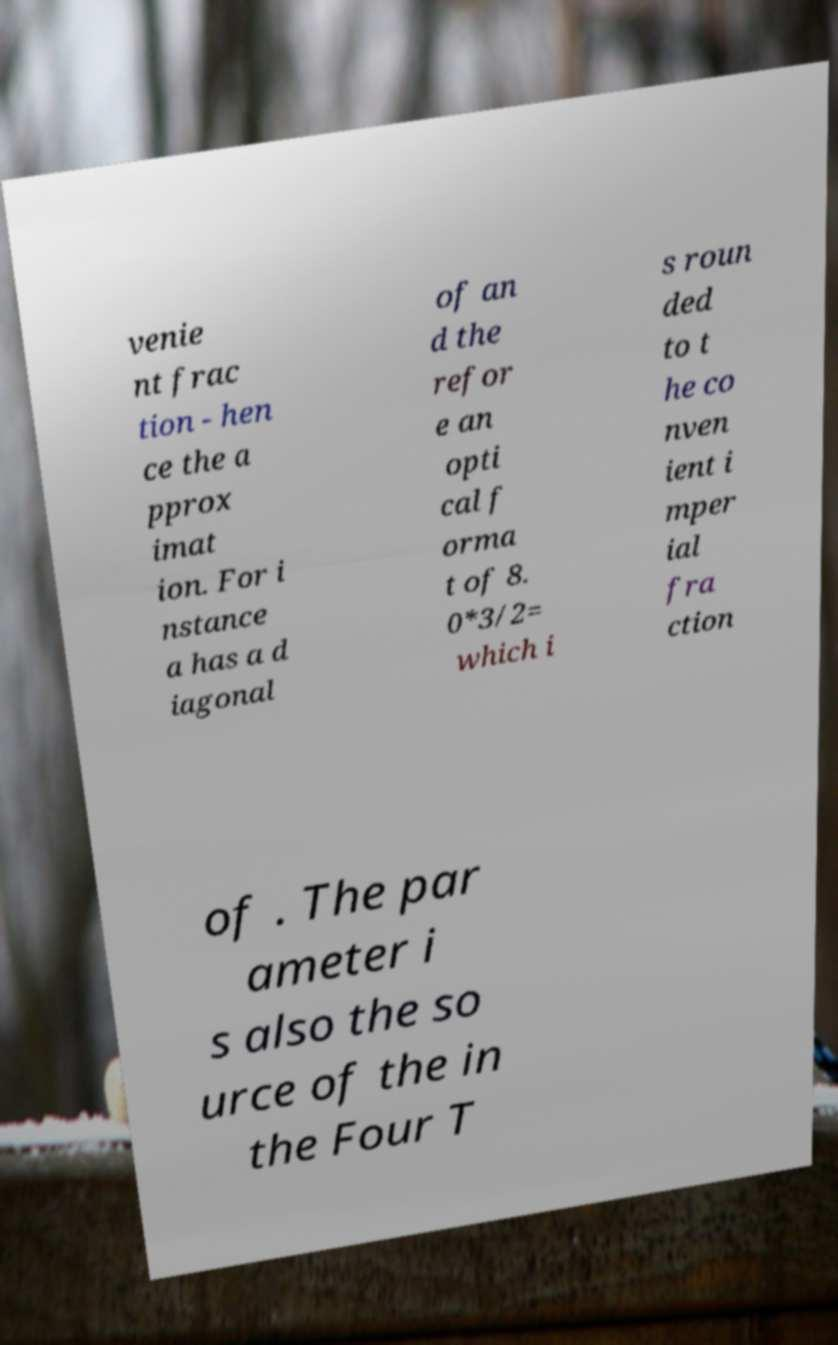There's text embedded in this image that I need extracted. Can you transcribe it verbatim? venie nt frac tion - hen ce the a pprox imat ion. For i nstance a has a d iagonal of an d the refor e an opti cal f orma t of 8. 0*3/2= which i s roun ded to t he co nven ient i mper ial fra ction of . The par ameter i s also the so urce of the in the Four T 